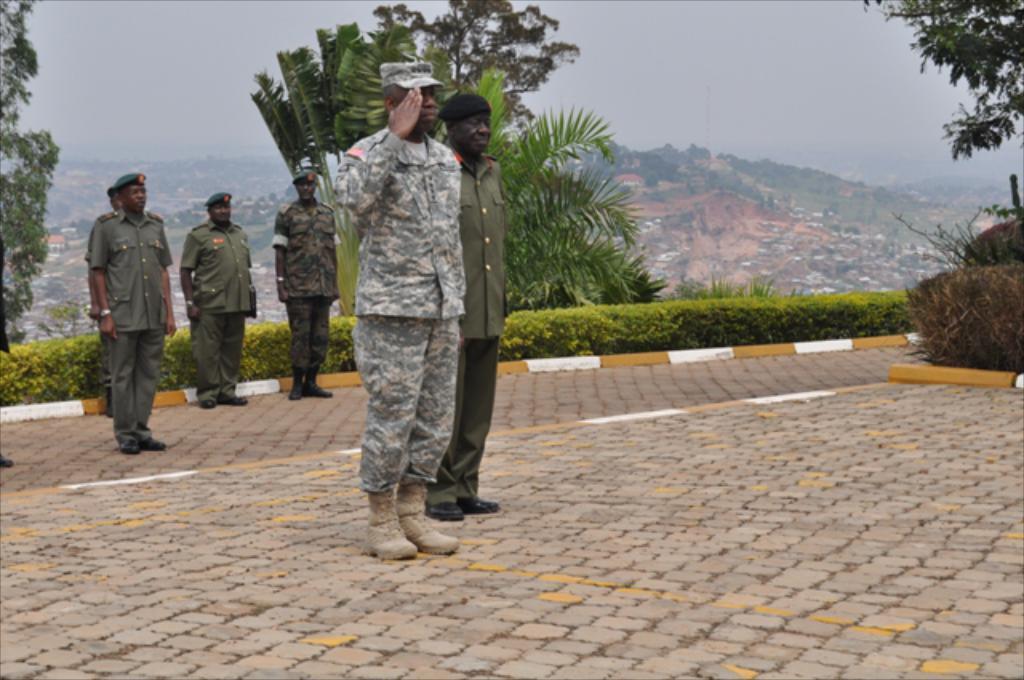Describe this image in one or two sentences. In this image there are some people standing on the road, behind them there are plants, trees and mountain. 